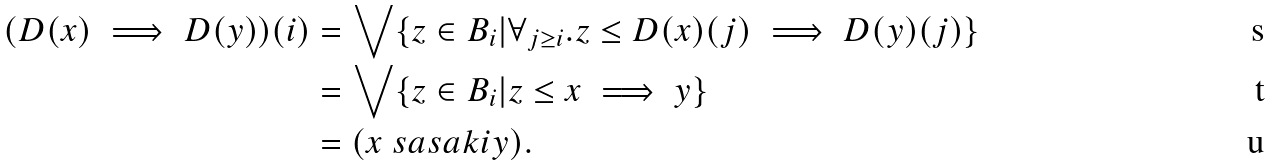Convert formula to latex. <formula><loc_0><loc_0><loc_500><loc_500>( D ( x ) \implies D ( y ) ) ( i ) & = \bigvee \{ z \in B _ { i } | \forall _ { j \geq i } . z \leq D ( x ) ( j ) \implies D ( y ) ( j ) \} \\ & = \bigvee \{ z \in B _ { i } | z \leq x \implies y \} \\ & = ( x \ s a s a k i y ) .</formula> 